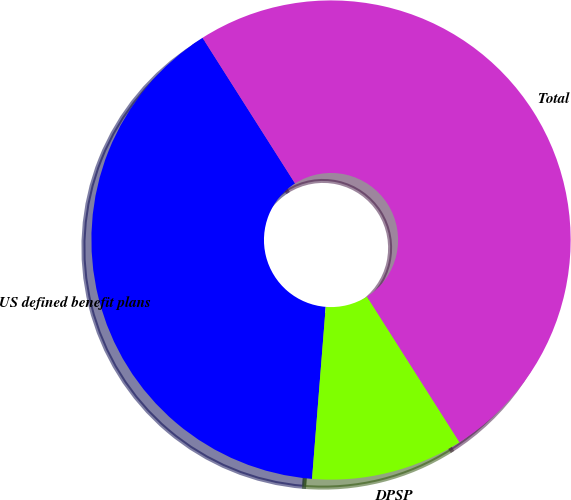Convert chart. <chart><loc_0><loc_0><loc_500><loc_500><pie_chart><fcel>US defined benefit plans<fcel>DPSP<fcel>Total<nl><fcel>39.73%<fcel>10.27%<fcel>50.0%<nl></chart> 